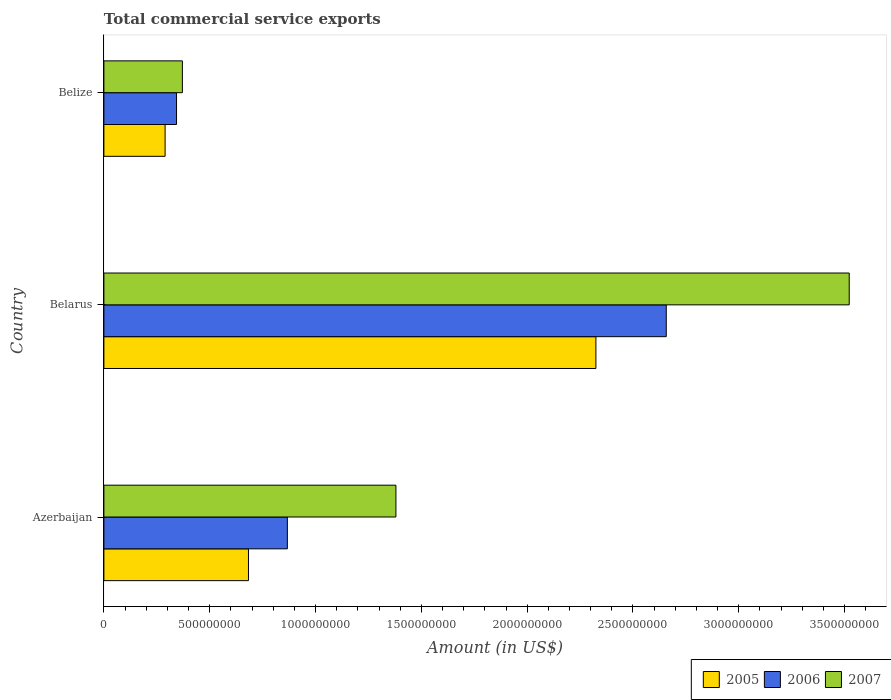How many different coloured bars are there?
Offer a very short reply. 3. How many groups of bars are there?
Make the answer very short. 3. What is the label of the 1st group of bars from the top?
Provide a succinct answer. Belize. In how many cases, is the number of bars for a given country not equal to the number of legend labels?
Provide a short and direct response. 0. What is the total commercial service exports in 2006 in Belize?
Give a very brief answer. 3.43e+08. Across all countries, what is the maximum total commercial service exports in 2007?
Offer a very short reply. 3.52e+09. Across all countries, what is the minimum total commercial service exports in 2005?
Offer a terse response. 2.89e+08. In which country was the total commercial service exports in 2007 maximum?
Offer a very short reply. Belarus. In which country was the total commercial service exports in 2006 minimum?
Your answer should be compact. Belize. What is the total total commercial service exports in 2006 in the graph?
Provide a succinct answer. 3.87e+09. What is the difference between the total commercial service exports in 2005 in Belarus and that in Belize?
Ensure brevity in your answer.  2.04e+09. What is the difference between the total commercial service exports in 2006 in Belize and the total commercial service exports in 2007 in Belarus?
Make the answer very short. -3.18e+09. What is the average total commercial service exports in 2007 per country?
Your answer should be compact. 1.76e+09. What is the difference between the total commercial service exports in 2005 and total commercial service exports in 2006 in Belarus?
Provide a succinct answer. -3.32e+08. What is the ratio of the total commercial service exports in 2005 in Belarus to that in Belize?
Your answer should be compact. 8.04. Is the total commercial service exports in 2007 in Azerbaijan less than that in Belize?
Your answer should be compact. No. What is the difference between the highest and the second highest total commercial service exports in 2006?
Offer a very short reply. 1.79e+09. What is the difference between the highest and the lowest total commercial service exports in 2006?
Provide a succinct answer. 2.31e+09. In how many countries, is the total commercial service exports in 2006 greater than the average total commercial service exports in 2006 taken over all countries?
Give a very brief answer. 1. Is the sum of the total commercial service exports in 2007 in Azerbaijan and Belarus greater than the maximum total commercial service exports in 2005 across all countries?
Provide a succinct answer. Yes. What does the 2nd bar from the top in Belarus represents?
Keep it short and to the point. 2006. How many bars are there?
Provide a short and direct response. 9. How many countries are there in the graph?
Offer a terse response. 3. What is the difference between two consecutive major ticks on the X-axis?
Keep it short and to the point. 5.00e+08. Are the values on the major ticks of X-axis written in scientific E-notation?
Your answer should be very brief. No. Where does the legend appear in the graph?
Provide a succinct answer. Bottom right. How many legend labels are there?
Provide a short and direct response. 3. What is the title of the graph?
Your answer should be compact. Total commercial service exports. What is the Amount (in US$) of 2005 in Azerbaijan?
Keep it short and to the point. 6.83e+08. What is the Amount (in US$) of 2006 in Azerbaijan?
Your answer should be very brief. 8.67e+08. What is the Amount (in US$) of 2007 in Azerbaijan?
Ensure brevity in your answer.  1.38e+09. What is the Amount (in US$) of 2005 in Belarus?
Ensure brevity in your answer.  2.32e+09. What is the Amount (in US$) of 2006 in Belarus?
Provide a succinct answer. 2.66e+09. What is the Amount (in US$) in 2007 in Belarus?
Offer a terse response. 3.52e+09. What is the Amount (in US$) of 2005 in Belize?
Make the answer very short. 2.89e+08. What is the Amount (in US$) of 2006 in Belize?
Your answer should be very brief. 3.43e+08. What is the Amount (in US$) of 2007 in Belize?
Make the answer very short. 3.71e+08. Across all countries, what is the maximum Amount (in US$) of 2005?
Provide a short and direct response. 2.32e+09. Across all countries, what is the maximum Amount (in US$) of 2006?
Provide a succinct answer. 2.66e+09. Across all countries, what is the maximum Amount (in US$) in 2007?
Make the answer very short. 3.52e+09. Across all countries, what is the minimum Amount (in US$) in 2005?
Make the answer very short. 2.89e+08. Across all countries, what is the minimum Amount (in US$) in 2006?
Provide a short and direct response. 3.43e+08. Across all countries, what is the minimum Amount (in US$) in 2007?
Offer a terse response. 3.71e+08. What is the total Amount (in US$) in 2005 in the graph?
Your response must be concise. 3.30e+09. What is the total Amount (in US$) in 2006 in the graph?
Your response must be concise. 3.87e+09. What is the total Amount (in US$) of 2007 in the graph?
Give a very brief answer. 5.27e+09. What is the difference between the Amount (in US$) in 2005 in Azerbaijan and that in Belarus?
Give a very brief answer. -1.64e+09. What is the difference between the Amount (in US$) of 2006 in Azerbaijan and that in Belarus?
Provide a short and direct response. -1.79e+09. What is the difference between the Amount (in US$) of 2007 in Azerbaijan and that in Belarus?
Your answer should be very brief. -2.14e+09. What is the difference between the Amount (in US$) in 2005 in Azerbaijan and that in Belize?
Ensure brevity in your answer.  3.94e+08. What is the difference between the Amount (in US$) of 2006 in Azerbaijan and that in Belize?
Give a very brief answer. 5.24e+08. What is the difference between the Amount (in US$) of 2007 in Azerbaijan and that in Belize?
Make the answer very short. 1.01e+09. What is the difference between the Amount (in US$) in 2005 in Belarus and that in Belize?
Offer a very short reply. 2.04e+09. What is the difference between the Amount (in US$) of 2006 in Belarus and that in Belize?
Your response must be concise. 2.31e+09. What is the difference between the Amount (in US$) in 2007 in Belarus and that in Belize?
Your answer should be compact. 3.15e+09. What is the difference between the Amount (in US$) of 2005 in Azerbaijan and the Amount (in US$) of 2006 in Belarus?
Keep it short and to the point. -1.97e+09. What is the difference between the Amount (in US$) of 2005 in Azerbaijan and the Amount (in US$) of 2007 in Belarus?
Make the answer very short. -2.84e+09. What is the difference between the Amount (in US$) in 2006 in Azerbaijan and the Amount (in US$) in 2007 in Belarus?
Provide a short and direct response. -2.65e+09. What is the difference between the Amount (in US$) in 2005 in Azerbaijan and the Amount (in US$) in 2006 in Belize?
Offer a terse response. 3.40e+08. What is the difference between the Amount (in US$) of 2005 in Azerbaijan and the Amount (in US$) of 2007 in Belize?
Your answer should be very brief. 3.12e+08. What is the difference between the Amount (in US$) of 2006 in Azerbaijan and the Amount (in US$) of 2007 in Belize?
Provide a succinct answer. 4.96e+08. What is the difference between the Amount (in US$) of 2005 in Belarus and the Amount (in US$) of 2006 in Belize?
Give a very brief answer. 1.98e+09. What is the difference between the Amount (in US$) of 2005 in Belarus and the Amount (in US$) of 2007 in Belize?
Give a very brief answer. 1.95e+09. What is the difference between the Amount (in US$) of 2006 in Belarus and the Amount (in US$) of 2007 in Belize?
Your answer should be very brief. 2.29e+09. What is the average Amount (in US$) of 2005 per country?
Offer a very short reply. 1.10e+09. What is the average Amount (in US$) in 2006 per country?
Provide a succinct answer. 1.29e+09. What is the average Amount (in US$) of 2007 per country?
Provide a succinct answer. 1.76e+09. What is the difference between the Amount (in US$) in 2005 and Amount (in US$) in 2006 in Azerbaijan?
Your answer should be compact. -1.84e+08. What is the difference between the Amount (in US$) of 2005 and Amount (in US$) of 2007 in Azerbaijan?
Offer a very short reply. -6.97e+08. What is the difference between the Amount (in US$) of 2006 and Amount (in US$) of 2007 in Azerbaijan?
Your answer should be very brief. -5.13e+08. What is the difference between the Amount (in US$) of 2005 and Amount (in US$) of 2006 in Belarus?
Make the answer very short. -3.32e+08. What is the difference between the Amount (in US$) in 2005 and Amount (in US$) in 2007 in Belarus?
Make the answer very short. -1.20e+09. What is the difference between the Amount (in US$) of 2006 and Amount (in US$) of 2007 in Belarus?
Provide a succinct answer. -8.64e+08. What is the difference between the Amount (in US$) of 2005 and Amount (in US$) of 2006 in Belize?
Give a very brief answer. -5.40e+07. What is the difference between the Amount (in US$) in 2005 and Amount (in US$) in 2007 in Belize?
Keep it short and to the point. -8.18e+07. What is the difference between the Amount (in US$) in 2006 and Amount (in US$) in 2007 in Belize?
Keep it short and to the point. -2.77e+07. What is the ratio of the Amount (in US$) of 2005 in Azerbaijan to that in Belarus?
Provide a succinct answer. 0.29. What is the ratio of the Amount (in US$) in 2006 in Azerbaijan to that in Belarus?
Give a very brief answer. 0.33. What is the ratio of the Amount (in US$) in 2007 in Azerbaijan to that in Belarus?
Make the answer very short. 0.39. What is the ratio of the Amount (in US$) of 2005 in Azerbaijan to that in Belize?
Your answer should be very brief. 2.36. What is the ratio of the Amount (in US$) in 2006 in Azerbaijan to that in Belize?
Your answer should be compact. 2.53. What is the ratio of the Amount (in US$) of 2007 in Azerbaijan to that in Belize?
Provide a succinct answer. 3.72. What is the ratio of the Amount (in US$) of 2005 in Belarus to that in Belize?
Your answer should be very brief. 8.04. What is the ratio of the Amount (in US$) in 2006 in Belarus to that in Belize?
Provide a short and direct response. 7.74. What is the ratio of the Amount (in US$) in 2007 in Belarus to that in Belize?
Ensure brevity in your answer.  9.49. What is the difference between the highest and the second highest Amount (in US$) of 2005?
Keep it short and to the point. 1.64e+09. What is the difference between the highest and the second highest Amount (in US$) in 2006?
Your answer should be very brief. 1.79e+09. What is the difference between the highest and the second highest Amount (in US$) in 2007?
Ensure brevity in your answer.  2.14e+09. What is the difference between the highest and the lowest Amount (in US$) in 2005?
Offer a very short reply. 2.04e+09. What is the difference between the highest and the lowest Amount (in US$) of 2006?
Keep it short and to the point. 2.31e+09. What is the difference between the highest and the lowest Amount (in US$) in 2007?
Your answer should be compact. 3.15e+09. 